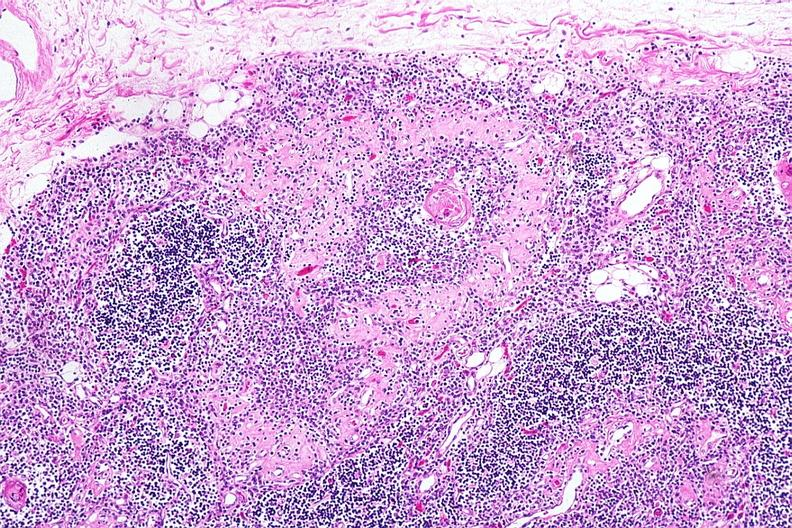s follicular fibrosis suggesting previous viral infection present?
Answer the question using a single word or phrase. Yes 